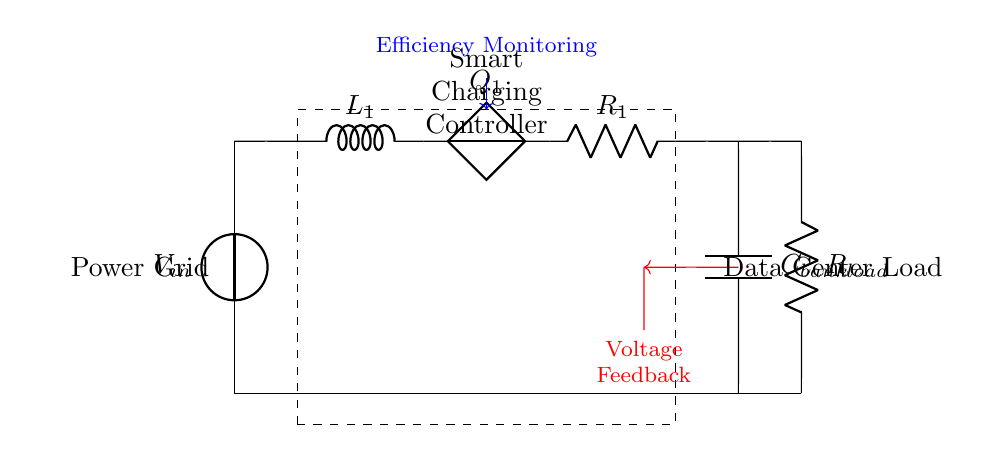What is the input voltage of this circuit? The input voltage is labeled as V_in, which is the source voltage supplied to the circuit.
Answer: V_in What component is used to control the charging? The circuit contains a Smart Charging Controller, indicated by the dashed rectangle, which manages the charging process.
Answer: Smart Charging Controller What does the capacitor bank do in this circuit? The capacitor bank, labeled as C_bank, stores energy and helps to stabilize the voltage in the circuit during charging.
Answer: Energy storage How is voltage feedback indicated in the diagram? The voltage feedback is represented by the red arrow pointing from the capacitor bank to the smart charging controller, indicating a monitoring loop.
Answer: Red arrow What is the resistor labeled as R_load? The resistor labeled R_load represents the load component that consumes power from the circuit, indicating the data center's energy usage.
Answer: Load resistor Explain how the efficiency monitoring is indicated in the diagram. The efficiency monitoring is shown by a blue arrow leading from the Smart Charging Controller to a point above it, symbolizing the assessment of the circuit's performance in terms of power usage and output.
Answer: Blue arrow What is the role of inductor L1 in this circuit? The inductor L1 is used to smooth the current flowing into the circuit, reducing spikes in current and aiding in efficient power management.
Answer: Current smoothing 